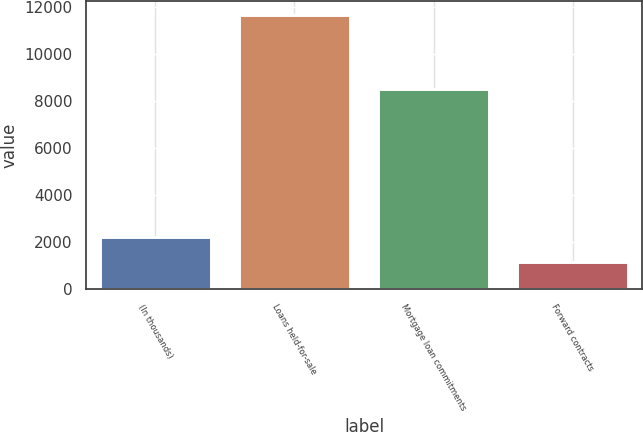<chart> <loc_0><loc_0><loc_500><loc_500><bar_chart><fcel>(In thousands)<fcel>Loans held-for-sale<fcel>Mortgage loan commitments<fcel>Forward contracts<nl><fcel>2214.8<fcel>11654<fcel>8521<fcel>1166<nl></chart> 